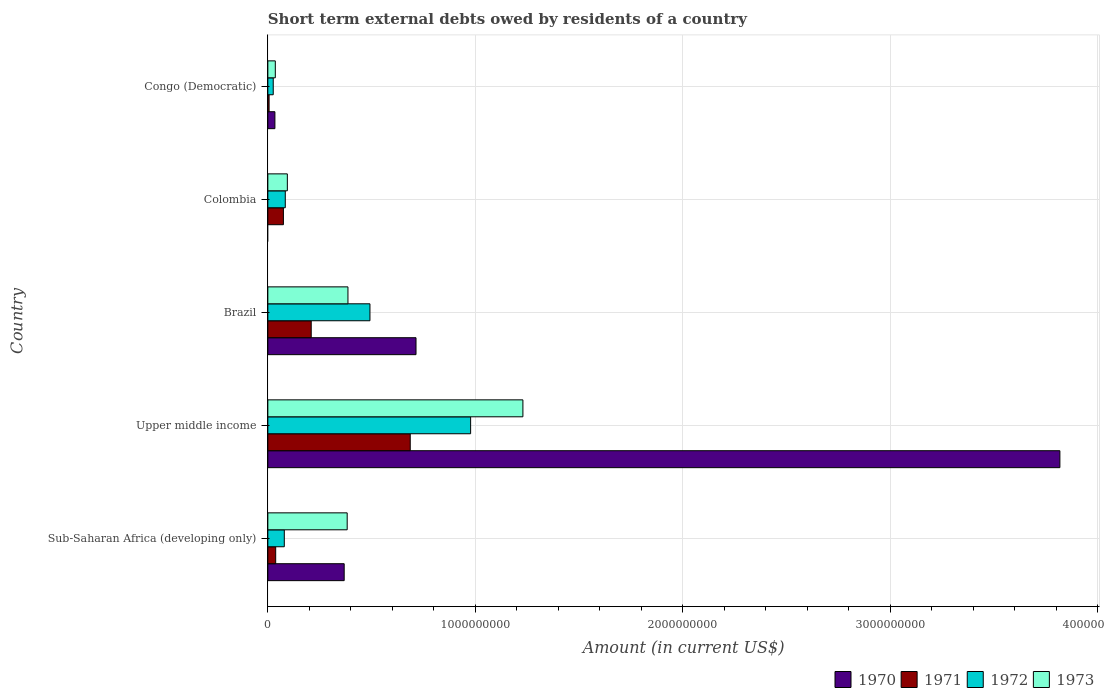How many bars are there on the 3rd tick from the bottom?
Your answer should be very brief. 4. What is the label of the 4th group of bars from the top?
Give a very brief answer. Upper middle income. In how many cases, is the number of bars for a given country not equal to the number of legend labels?
Your answer should be very brief. 1. What is the amount of short-term external debts owed by residents in 1970 in Upper middle income?
Your response must be concise. 3.82e+09. Across all countries, what is the maximum amount of short-term external debts owed by residents in 1970?
Make the answer very short. 3.82e+09. Across all countries, what is the minimum amount of short-term external debts owed by residents in 1972?
Your response must be concise. 2.60e+07. In which country was the amount of short-term external debts owed by residents in 1973 maximum?
Provide a succinct answer. Upper middle income. What is the total amount of short-term external debts owed by residents in 1971 in the graph?
Your response must be concise. 1.01e+09. What is the difference between the amount of short-term external debts owed by residents in 1972 in Congo (Democratic) and that in Sub-Saharan Africa (developing only)?
Provide a short and direct response. -5.33e+07. What is the difference between the amount of short-term external debts owed by residents in 1971 in Sub-Saharan Africa (developing only) and the amount of short-term external debts owed by residents in 1973 in Colombia?
Offer a very short reply. -5.62e+07. What is the average amount of short-term external debts owed by residents in 1970 per country?
Give a very brief answer. 9.87e+08. What is the difference between the amount of short-term external debts owed by residents in 1970 and amount of short-term external debts owed by residents in 1971 in Congo (Democratic)?
Your answer should be very brief. 2.80e+07. In how many countries, is the amount of short-term external debts owed by residents in 1972 greater than 3800000000 US$?
Provide a short and direct response. 0. What is the ratio of the amount of short-term external debts owed by residents in 1971 in Brazil to that in Sub-Saharan Africa (developing only)?
Your answer should be very brief. 5.53. Is the amount of short-term external debts owed by residents in 1971 in Colombia less than that in Sub-Saharan Africa (developing only)?
Keep it short and to the point. No. Is the difference between the amount of short-term external debts owed by residents in 1970 in Brazil and Upper middle income greater than the difference between the amount of short-term external debts owed by residents in 1971 in Brazil and Upper middle income?
Your response must be concise. No. What is the difference between the highest and the second highest amount of short-term external debts owed by residents in 1972?
Provide a short and direct response. 4.85e+08. What is the difference between the highest and the lowest amount of short-term external debts owed by residents in 1973?
Ensure brevity in your answer.  1.19e+09. Is the sum of the amount of short-term external debts owed by residents in 1971 in Brazil and Upper middle income greater than the maximum amount of short-term external debts owed by residents in 1972 across all countries?
Ensure brevity in your answer.  No. Is it the case that in every country, the sum of the amount of short-term external debts owed by residents in 1971 and amount of short-term external debts owed by residents in 1972 is greater than the amount of short-term external debts owed by residents in 1973?
Offer a terse response. No. How many bars are there?
Your response must be concise. 19. Are all the bars in the graph horizontal?
Provide a succinct answer. Yes. How many countries are there in the graph?
Give a very brief answer. 5. What is the difference between two consecutive major ticks on the X-axis?
Offer a very short reply. 1.00e+09. Are the values on the major ticks of X-axis written in scientific E-notation?
Give a very brief answer. No. Does the graph contain any zero values?
Your answer should be compact. Yes. Does the graph contain grids?
Give a very brief answer. Yes. Where does the legend appear in the graph?
Your answer should be very brief. Bottom right. How many legend labels are there?
Keep it short and to the point. 4. What is the title of the graph?
Ensure brevity in your answer.  Short term external debts owed by residents of a country. What is the Amount (in current US$) of 1970 in Sub-Saharan Africa (developing only)?
Ensure brevity in your answer.  3.68e+08. What is the Amount (in current US$) in 1971 in Sub-Saharan Africa (developing only)?
Make the answer very short. 3.78e+07. What is the Amount (in current US$) of 1972 in Sub-Saharan Africa (developing only)?
Your response must be concise. 7.93e+07. What is the Amount (in current US$) in 1973 in Sub-Saharan Africa (developing only)?
Give a very brief answer. 3.82e+08. What is the Amount (in current US$) of 1970 in Upper middle income?
Offer a very short reply. 3.82e+09. What is the Amount (in current US$) of 1971 in Upper middle income?
Your response must be concise. 6.86e+08. What is the Amount (in current US$) of 1972 in Upper middle income?
Offer a terse response. 9.77e+08. What is the Amount (in current US$) in 1973 in Upper middle income?
Your answer should be compact. 1.23e+09. What is the Amount (in current US$) in 1970 in Brazil?
Give a very brief answer. 7.14e+08. What is the Amount (in current US$) in 1971 in Brazil?
Provide a succinct answer. 2.09e+08. What is the Amount (in current US$) of 1972 in Brazil?
Offer a terse response. 4.92e+08. What is the Amount (in current US$) of 1973 in Brazil?
Give a very brief answer. 3.86e+08. What is the Amount (in current US$) in 1970 in Colombia?
Your answer should be very brief. 0. What is the Amount (in current US$) of 1971 in Colombia?
Offer a very short reply. 7.50e+07. What is the Amount (in current US$) of 1972 in Colombia?
Provide a short and direct response. 8.40e+07. What is the Amount (in current US$) in 1973 in Colombia?
Your answer should be very brief. 9.40e+07. What is the Amount (in current US$) of 1970 in Congo (Democratic)?
Provide a short and direct response. 3.40e+07. What is the Amount (in current US$) in 1972 in Congo (Democratic)?
Ensure brevity in your answer.  2.60e+07. What is the Amount (in current US$) in 1973 in Congo (Democratic)?
Make the answer very short. 3.60e+07. Across all countries, what is the maximum Amount (in current US$) of 1970?
Your answer should be very brief. 3.82e+09. Across all countries, what is the maximum Amount (in current US$) in 1971?
Provide a succinct answer. 6.86e+08. Across all countries, what is the maximum Amount (in current US$) of 1972?
Your answer should be compact. 9.77e+08. Across all countries, what is the maximum Amount (in current US$) in 1973?
Your answer should be very brief. 1.23e+09. Across all countries, what is the minimum Amount (in current US$) in 1970?
Your answer should be very brief. 0. Across all countries, what is the minimum Amount (in current US$) in 1972?
Ensure brevity in your answer.  2.60e+07. Across all countries, what is the minimum Amount (in current US$) in 1973?
Provide a succinct answer. 3.60e+07. What is the total Amount (in current US$) of 1970 in the graph?
Your response must be concise. 4.93e+09. What is the total Amount (in current US$) of 1971 in the graph?
Your answer should be very brief. 1.01e+09. What is the total Amount (in current US$) in 1972 in the graph?
Your answer should be compact. 1.66e+09. What is the total Amount (in current US$) in 1973 in the graph?
Your answer should be very brief. 2.13e+09. What is the difference between the Amount (in current US$) in 1970 in Sub-Saharan Africa (developing only) and that in Upper middle income?
Ensure brevity in your answer.  -3.45e+09. What is the difference between the Amount (in current US$) of 1971 in Sub-Saharan Africa (developing only) and that in Upper middle income?
Offer a very short reply. -6.48e+08. What is the difference between the Amount (in current US$) in 1972 in Sub-Saharan Africa (developing only) and that in Upper middle income?
Provide a short and direct response. -8.98e+08. What is the difference between the Amount (in current US$) of 1973 in Sub-Saharan Africa (developing only) and that in Upper middle income?
Your response must be concise. -8.47e+08. What is the difference between the Amount (in current US$) in 1970 in Sub-Saharan Africa (developing only) and that in Brazil?
Your answer should be very brief. -3.46e+08. What is the difference between the Amount (in current US$) in 1971 in Sub-Saharan Africa (developing only) and that in Brazil?
Provide a short and direct response. -1.71e+08. What is the difference between the Amount (in current US$) in 1972 in Sub-Saharan Africa (developing only) and that in Brazil?
Offer a very short reply. -4.13e+08. What is the difference between the Amount (in current US$) of 1973 in Sub-Saharan Africa (developing only) and that in Brazil?
Make the answer very short. -3.69e+06. What is the difference between the Amount (in current US$) in 1971 in Sub-Saharan Africa (developing only) and that in Colombia?
Your response must be concise. -3.72e+07. What is the difference between the Amount (in current US$) in 1972 in Sub-Saharan Africa (developing only) and that in Colombia?
Offer a terse response. -4.69e+06. What is the difference between the Amount (in current US$) of 1973 in Sub-Saharan Africa (developing only) and that in Colombia?
Provide a succinct answer. 2.88e+08. What is the difference between the Amount (in current US$) in 1970 in Sub-Saharan Africa (developing only) and that in Congo (Democratic)?
Give a very brief answer. 3.34e+08. What is the difference between the Amount (in current US$) in 1971 in Sub-Saharan Africa (developing only) and that in Congo (Democratic)?
Keep it short and to the point. 3.18e+07. What is the difference between the Amount (in current US$) of 1972 in Sub-Saharan Africa (developing only) and that in Congo (Democratic)?
Ensure brevity in your answer.  5.33e+07. What is the difference between the Amount (in current US$) in 1973 in Sub-Saharan Africa (developing only) and that in Congo (Democratic)?
Offer a very short reply. 3.46e+08. What is the difference between the Amount (in current US$) in 1970 in Upper middle income and that in Brazil?
Ensure brevity in your answer.  3.10e+09. What is the difference between the Amount (in current US$) in 1971 in Upper middle income and that in Brazil?
Your answer should be very brief. 4.77e+08. What is the difference between the Amount (in current US$) of 1972 in Upper middle income and that in Brazil?
Your answer should be compact. 4.85e+08. What is the difference between the Amount (in current US$) in 1973 in Upper middle income and that in Brazil?
Offer a very short reply. 8.43e+08. What is the difference between the Amount (in current US$) of 1971 in Upper middle income and that in Colombia?
Ensure brevity in your answer.  6.11e+08. What is the difference between the Amount (in current US$) in 1972 in Upper middle income and that in Colombia?
Offer a terse response. 8.93e+08. What is the difference between the Amount (in current US$) of 1973 in Upper middle income and that in Colombia?
Offer a terse response. 1.14e+09. What is the difference between the Amount (in current US$) in 1970 in Upper middle income and that in Congo (Democratic)?
Offer a very short reply. 3.78e+09. What is the difference between the Amount (in current US$) of 1971 in Upper middle income and that in Congo (Democratic)?
Your answer should be compact. 6.80e+08. What is the difference between the Amount (in current US$) of 1972 in Upper middle income and that in Congo (Democratic)?
Offer a terse response. 9.51e+08. What is the difference between the Amount (in current US$) of 1973 in Upper middle income and that in Congo (Democratic)?
Offer a very short reply. 1.19e+09. What is the difference between the Amount (in current US$) of 1971 in Brazil and that in Colombia?
Your response must be concise. 1.34e+08. What is the difference between the Amount (in current US$) of 1972 in Brazil and that in Colombia?
Your answer should be very brief. 4.08e+08. What is the difference between the Amount (in current US$) of 1973 in Brazil and that in Colombia?
Offer a terse response. 2.92e+08. What is the difference between the Amount (in current US$) of 1970 in Brazil and that in Congo (Democratic)?
Your answer should be very brief. 6.80e+08. What is the difference between the Amount (in current US$) of 1971 in Brazil and that in Congo (Democratic)?
Make the answer very short. 2.03e+08. What is the difference between the Amount (in current US$) in 1972 in Brazil and that in Congo (Democratic)?
Offer a terse response. 4.66e+08. What is the difference between the Amount (in current US$) of 1973 in Brazil and that in Congo (Democratic)?
Provide a short and direct response. 3.50e+08. What is the difference between the Amount (in current US$) of 1971 in Colombia and that in Congo (Democratic)?
Make the answer very short. 6.90e+07. What is the difference between the Amount (in current US$) of 1972 in Colombia and that in Congo (Democratic)?
Provide a short and direct response. 5.80e+07. What is the difference between the Amount (in current US$) of 1973 in Colombia and that in Congo (Democratic)?
Make the answer very short. 5.80e+07. What is the difference between the Amount (in current US$) in 1970 in Sub-Saharan Africa (developing only) and the Amount (in current US$) in 1971 in Upper middle income?
Your answer should be very brief. -3.18e+08. What is the difference between the Amount (in current US$) in 1970 in Sub-Saharan Africa (developing only) and the Amount (in current US$) in 1972 in Upper middle income?
Offer a terse response. -6.09e+08. What is the difference between the Amount (in current US$) in 1970 in Sub-Saharan Africa (developing only) and the Amount (in current US$) in 1973 in Upper middle income?
Offer a terse response. -8.61e+08. What is the difference between the Amount (in current US$) of 1971 in Sub-Saharan Africa (developing only) and the Amount (in current US$) of 1972 in Upper middle income?
Offer a terse response. -9.39e+08. What is the difference between the Amount (in current US$) in 1971 in Sub-Saharan Africa (developing only) and the Amount (in current US$) in 1973 in Upper middle income?
Offer a very short reply. -1.19e+09. What is the difference between the Amount (in current US$) of 1972 in Sub-Saharan Africa (developing only) and the Amount (in current US$) of 1973 in Upper middle income?
Offer a very short reply. -1.15e+09. What is the difference between the Amount (in current US$) in 1970 in Sub-Saharan Africa (developing only) and the Amount (in current US$) in 1971 in Brazil?
Provide a short and direct response. 1.59e+08. What is the difference between the Amount (in current US$) of 1970 in Sub-Saharan Africa (developing only) and the Amount (in current US$) of 1972 in Brazil?
Provide a succinct answer. -1.24e+08. What is the difference between the Amount (in current US$) of 1970 in Sub-Saharan Africa (developing only) and the Amount (in current US$) of 1973 in Brazil?
Give a very brief answer. -1.81e+07. What is the difference between the Amount (in current US$) in 1971 in Sub-Saharan Africa (developing only) and the Amount (in current US$) in 1972 in Brazil?
Provide a succinct answer. -4.54e+08. What is the difference between the Amount (in current US$) of 1971 in Sub-Saharan Africa (developing only) and the Amount (in current US$) of 1973 in Brazil?
Offer a very short reply. -3.48e+08. What is the difference between the Amount (in current US$) in 1972 in Sub-Saharan Africa (developing only) and the Amount (in current US$) in 1973 in Brazil?
Make the answer very short. -3.07e+08. What is the difference between the Amount (in current US$) of 1970 in Sub-Saharan Africa (developing only) and the Amount (in current US$) of 1971 in Colombia?
Your answer should be very brief. 2.93e+08. What is the difference between the Amount (in current US$) in 1970 in Sub-Saharan Africa (developing only) and the Amount (in current US$) in 1972 in Colombia?
Provide a succinct answer. 2.84e+08. What is the difference between the Amount (in current US$) of 1970 in Sub-Saharan Africa (developing only) and the Amount (in current US$) of 1973 in Colombia?
Ensure brevity in your answer.  2.74e+08. What is the difference between the Amount (in current US$) of 1971 in Sub-Saharan Africa (developing only) and the Amount (in current US$) of 1972 in Colombia?
Ensure brevity in your answer.  -4.62e+07. What is the difference between the Amount (in current US$) in 1971 in Sub-Saharan Africa (developing only) and the Amount (in current US$) in 1973 in Colombia?
Offer a very short reply. -5.62e+07. What is the difference between the Amount (in current US$) of 1972 in Sub-Saharan Africa (developing only) and the Amount (in current US$) of 1973 in Colombia?
Ensure brevity in your answer.  -1.47e+07. What is the difference between the Amount (in current US$) of 1970 in Sub-Saharan Africa (developing only) and the Amount (in current US$) of 1971 in Congo (Democratic)?
Keep it short and to the point. 3.62e+08. What is the difference between the Amount (in current US$) of 1970 in Sub-Saharan Africa (developing only) and the Amount (in current US$) of 1972 in Congo (Democratic)?
Your answer should be very brief. 3.42e+08. What is the difference between the Amount (in current US$) of 1970 in Sub-Saharan Africa (developing only) and the Amount (in current US$) of 1973 in Congo (Democratic)?
Make the answer very short. 3.32e+08. What is the difference between the Amount (in current US$) of 1971 in Sub-Saharan Africa (developing only) and the Amount (in current US$) of 1972 in Congo (Democratic)?
Give a very brief answer. 1.18e+07. What is the difference between the Amount (in current US$) of 1971 in Sub-Saharan Africa (developing only) and the Amount (in current US$) of 1973 in Congo (Democratic)?
Provide a succinct answer. 1.81e+06. What is the difference between the Amount (in current US$) of 1972 in Sub-Saharan Africa (developing only) and the Amount (in current US$) of 1973 in Congo (Democratic)?
Your response must be concise. 4.33e+07. What is the difference between the Amount (in current US$) of 1970 in Upper middle income and the Amount (in current US$) of 1971 in Brazil?
Offer a very short reply. 3.61e+09. What is the difference between the Amount (in current US$) of 1970 in Upper middle income and the Amount (in current US$) of 1972 in Brazil?
Make the answer very short. 3.32e+09. What is the difference between the Amount (in current US$) in 1970 in Upper middle income and the Amount (in current US$) in 1973 in Brazil?
Your answer should be very brief. 3.43e+09. What is the difference between the Amount (in current US$) in 1971 in Upper middle income and the Amount (in current US$) in 1972 in Brazil?
Offer a terse response. 1.94e+08. What is the difference between the Amount (in current US$) of 1971 in Upper middle income and the Amount (in current US$) of 1973 in Brazil?
Your answer should be compact. 3.00e+08. What is the difference between the Amount (in current US$) in 1972 in Upper middle income and the Amount (in current US$) in 1973 in Brazil?
Give a very brief answer. 5.91e+08. What is the difference between the Amount (in current US$) in 1970 in Upper middle income and the Amount (in current US$) in 1971 in Colombia?
Your answer should be compact. 3.74e+09. What is the difference between the Amount (in current US$) of 1970 in Upper middle income and the Amount (in current US$) of 1972 in Colombia?
Your response must be concise. 3.73e+09. What is the difference between the Amount (in current US$) in 1970 in Upper middle income and the Amount (in current US$) in 1973 in Colombia?
Ensure brevity in your answer.  3.72e+09. What is the difference between the Amount (in current US$) of 1971 in Upper middle income and the Amount (in current US$) of 1972 in Colombia?
Make the answer very short. 6.02e+08. What is the difference between the Amount (in current US$) in 1971 in Upper middle income and the Amount (in current US$) in 1973 in Colombia?
Your response must be concise. 5.92e+08. What is the difference between the Amount (in current US$) in 1972 in Upper middle income and the Amount (in current US$) in 1973 in Colombia?
Provide a short and direct response. 8.83e+08. What is the difference between the Amount (in current US$) in 1970 in Upper middle income and the Amount (in current US$) in 1971 in Congo (Democratic)?
Provide a short and direct response. 3.81e+09. What is the difference between the Amount (in current US$) of 1970 in Upper middle income and the Amount (in current US$) of 1972 in Congo (Democratic)?
Ensure brevity in your answer.  3.79e+09. What is the difference between the Amount (in current US$) of 1970 in Upper middle income and the Amount (in current US$) of 1973 in Congo (Democratic)?
Offer a terse response. 3.78e+09. What is the difference between the Amount (in current US$) of 1971 in Upper middle income and the Amount (in current US$) of 1972 in Congo (Democratic)?
Your answer should be compact. 6.60e+08. What is the difference between the Amount (in current US$) in 1971 in Upper middle income and the Amount (in current US$) in 1973 in Congo (Democratic)?
Give a very brief answer. 6.50e+08. What is the difference between the Amount (in current US$) of 1972 in Upper middle income and the Amount (in current US$) of 1973 in Congo (Democratic)?
Keep it short and to the point. 9.41e+08. What is the difference between the Amount (in current US$) in 1970 in Brazil and the Amount (in current US$) in 1971 in Colombia?
Provide a succinct answer. 6.39e+08. What is the difference between the Amount (in current US$) in 1970 in Brazil and the Amount (in current US$) in 1972 in Colombia?
Ensure brevity in your answer.  6.30e+08. What is the difference between the Amount (in current US$) in 1970 in Brazil and the Amount (in current US$) in 1973 in Colombia?
Your answer should be compact. 6.20e+08. What is the difference between the Amount (in current US$) of 1971 in Brazil and the Amount (in current US$) of 1972 in Colombia?
Your answer should be very brief. 1.25e+08. What is the difference between the Amount (in current US$) of 1971 in Brazil and the Amount (in current US$) of 1973 in Colombia?
Make the answer very short. 1.15e+08. What is the difference between the Amount (in current US$) in 1972 in Brazil and the Amount (in current US$) in 1973 in Colombia?
Give a very brief answer. 3.98e+08. What is the difference between the Amount (in current US$) in 1970 in Brazil and the Amount (in current US$) in 1971 in Congo (Democratic)?
Give a very brief answer. 7.08e+08. What is the difference between the Amount (in current US$) in 1970 in Brazil and the Amount (in current US$) in 1972 in Congo (Democratic)?
Your response must be concise. 6.88e+08. What is the difference between the Amount (in current US$) of 1970 in Brazil and the Amount (in current US$) of 1973 in Congo (Democratic)?
Give a very brief answer. 6.78e+08. What is the difference between the Amount (in current US$) in 1971 in Brazil and the Amount (in current US$) in 1972 in Congo (Democratic)?
Keep it short and to the point. 1.83e+08. What is the difference between the Amount (in current US$) in 1971 in Brazil and the Amount (in current US$) in 1973 in Congo (Democratic)?
Provide a short and direct response. 1.73e+08. What is the difference between the Amount (in current US$) of 1972 in Brazil and the Amount (in current US$) of 1973 in Congo (Democratic)?
Provide a succinct answer. 4.56e+08. What is the difference between the Amount (in current US$) in 1971 in Colombia and the Amount (in current US$) in 1972 in Congo (Democratic)?
Provide a short and direct response. 4.90e+07. What is the difference between the Amount (in current US$) of 1971 in Colombia and the Amount (in current US$) of 1973 in Congo (Democratic)?
Your response must be concise. 3.90e+07. What is the difference between the Amount (in current US$) in 1972 in Colombia and the Amount (in current US$) in 1973 in Congo (Democratic)?
Offer a terse response. 4.80e+07. What is the average Amount (in current US$) in 1970 per country?
Ensure brevity in your answer.  9.87e+08. What is the average Amount (in current US$) of 1971 per country?
Provide a short and direct response. 2.03e+08. What is the average Amount (in current US$) in 1972 per country?
Your response must be concise. 3.32e+08. What is the average Amount (in current US$) of 1973 per country?
Provide a succinct answer. 4.25e+08. What is the difference between the Amount (in current US$) in 1970 and Amount (in current US$) in 1971 in Sub-Saharan Africa (developing only)?
Keep it short and to the point. 3.30e+08. What is the difference between the Amount (in current US$) of 1970 and Amount (in current US$) of 1972 in Sub-Saharan Africa (developing only)?
Provide a short and direct response. 2.89e+08. What is the difference between the Amount (in current US$) of 1970 and Amount (in current US$) of 1973 in Sub-Saharan Africa (developing only)?
Keep it short and to the point. -1.44e+07. What is the difference between the Amount (in current US$) in 1971 and Amount (in current US$) in 1972 in Sub-Saharan Africa (developing only)?
Ensure brevity in your answer.  -4.15e+07. What is the difference between the Amount (in current US$) in 1971 and Amount (in current US$) in 1973 in Sub-Saharan Africa (developing only)?
Keep it short and to the point. -3.45e+08. What is the difference between the Amount (in current US$) of 1972 and Amount (in current US$) of 1973 in Sub-Saharan Africa (developing only)?
Offer a terse response. -3.03e+08. What is the difference between the Amount (in current US$) of 1970 and Amount (in current US$) of 1971 in Upper middle income?
Keep it short and to the point. 3.13e+09. What is the difference between the Amount (in current US$) in 1970 and Amount (in current US$) in 1972 in Upper middle income?
Your answer should be compact. 2.84e+09. What is the difference between the Amount (in current US$) in 1970 and Amount (in current US$) in 1973 in Upper middle income?
Make the answer very short. 2.59e+09. What is the difference between the Amount (in current US$) in 1971 and Amount (in current US$) in 1972 in Upper middle income?
Provide a succinct answer. -2.91e+08. What is the difference between the Amount (in current US$) in 1971 and Amount (in current US$) in 1973 in Upper middle income?
Provide a short and direct response. -5.43e+08. What is the difference between the Amount (in current US$) of 1972 and Amount (in current US$) of 1973 in Upper middle income?
Your answer should be compact. -2.52e+08. What is the difference between the Amount (in current US$) of 1970 and Amount (in current US$) of 1971 in Brazil?
Keep it short and to the point. 5.05e+08. What is the difference between the Amount (in current US$) in 1970 and Amount (in current US$) in 1972 in Brazil?
Offer a terse response. 2.22e+08. What is the difference between the Amount (in current US$) of 1970 and Amount (in current US$) of 1973 in Brazil?
Your answer should be very brief. 3.28e+08. What is the difference between the Amount (in current US$) in 1971 and Amount (in current US$) in 1972 in Brazil?
Provide a short and direct response. -2.83e+08. What is the difference between the Amount (in current US$) in 1971 and Amount (in current US$) in 1973 in Brazil?
Your response must be concise. -1.77e+08. What is the difference between the Amount (in current US$) in 1972 and Amount (in current US$) in 1973 in Brazil?
Your answer should be very brief. 1.06e+08. What is the difference between the Amount (in current US$) of 1971 and Amount (in current US$) of 1972 in Colombia?
Ensure brevity in your answer.  -9.00e+06. What is the difference between the Amount (in current US$) of 1971 and Amount (in current US$) of 1973 in Colombia?
Keep it short and to the point. -1.90e+07. What is the difference between the Amount (in current US$) in 1972 and Amount (in current US$) in 1973 in Colombia?
Provide a short and direct response. -1.00e+07. What is the difference between the Amount (in current US$) of 1970 and Amount (in current US$) of 1971 in Congo (Democratic)?
Ensure brevity in your answer.  2.80e+07. What is the difference between the Amount (in current US$) in 1970 and Amount (in current US$) in 1972 in Congo (Democratic)?
Your answer should be compact. 8.00e+06. What is the difference between the Amount (in current US$) in 1971 and Amount (in current US$) in 1972 in Congo (Democratic)?
Keep it short and to the point. -2.00e+07. What is the difference between the Amount (in current US$) in 1971 and Amount (in current US$) in 1973 in Congo (Democratic)?
Your answer should be very brief. -3.00e+07. What is the difference between the Amount (in current US$) in 1972 and Amount (in current US$) in 1973 in Congo (Democratic)?
Keep it short and to the point. -1.00e+07. What is the ratio of the Amount (in current US$) of 1970 in Sub-Saharan Africa (developing only) to that in Upper middle income?
Provide a succinct answer. 0.1. What is the ratio of the Amount (in current US$) of 1971 in Sub-Saharan Africa (developing only) to that in Upper middle income?
Your response must be concise. 0.06. What is the ratio of the Amount (in current US$) of 1972 in Sub-Saharan Africa (developing only) to that in Upper middle income?
Provide a succinct answer. 0.08. What is the ratio of the Amount (in current US$) of 1973 in Sub-Saharan Africa (developing only) to that in Upper middle income?
Provide a succinct answer. 0.31. What is the ratio of the Amount (in current US$) of 1970 in Sub-Saharan Africa (developing only) to that in Brazil?
Your answer should be compact. 0.52. What is the ratio of the Amount (in current US$) in 1971 in Sub-Saharan Africa (developing only) to that in Brazil?
Make the answer very short. 0.18. What is the ratio of the Amount (in current US$) in 1972 in Sub-Saharan Africa (developing only) to that in Brazil?
Your response must be concise. 0.16. What is the ratio of the Amount (in current US$) in 1971 in Sub-Saharan Africa (developing only) to that in Colombia?
Give a very brief answer. 0.5. What is the ratio of the Amount (in current US$) of 1972 in Sub-Saharan Africa (developing only) to that in Colombia?
Your response must be concise. 0.94. What is the ratio of the Amount (in current US$) in 1973 in Sub-Saharan Africa (developing only) to that in Colombia?
Provide a succinct answer. 4.07. What is the ratio of the Amount (in current US$) in 1970 in Sub-Saharan Africa (developing only) to that in Congo (Democratic)?
Your answer should be very brief. 10.82. What is the ratio of the Amount (in current US$) of 1971 in Sub-Saharan Africa (developing only) to that in Congo (Democratic)?
Your response must be concise. 6.3. What is the ratio of the Amount (in current US$) of 1972 in Sub-Saharan Africa (developing only) to that in Congo (Democratic)?
Offer a terse response. 3.05. What is the ratio of the Amount (in current US$) of 1973 in Sub-Saharan Africa (developing only) to that in Congo (Democratic)?
Provide a short and direct response. 10.62. What is the ratio of the Amount (in current US$) of 1970 in Upper middle income to that in Brazil?
Keep it short and to the point. 5.35. What is the ratio of the Amount (in current US$) of 1971 in Upper middle income to that in Brazil?
Give a very brief answer. 3.28. What is the ratio of the Amount (in current US$) in 1972 in Upper middle income to that in Brazil?
Ensure brevity in your answer.  1.99. What is the ratio of the Amount (in current US$) of 1973 in Upper middle income to that in Brazil?
Provide a succinct answer. 3.18. What is the ratio of the Amount (in current US$) of 1971 in Upper middle income to that in Colombia?
Provide a short and direct response. 9.15. What is the ratio of the Amount (in current US$) in 1972 in Upper middle income to that in Colombia?
Keep it short and to the point. 11.63. What is the ratio of the Amount (in current US$) in 1973 in Upper middle income to that in Colombia?
Ensure brevity in your answer.  13.08. What is the ratio of the Amount (in current US$) of 1970 in Upper middle income to that in Congo (Democratic)?
Offer a terse response. 112.25. What is the ratio of the Amount (in current US$) in 1971 in Upper middle income to that in Congo (Democratic)?
Your answer should be compact. 114.35. What is the ratio of the Amount (in current US$) of 1972 in Upper middle income to that in Congo (Democratic)?
Provide a short and direct response. 37.58. What is the ratio of the Amount (in current US$) in 1973 in Upper middle income to that in Congo (Democratic)?
Provide a short and direct response. 34.14. What is the ratio of the Amount (in current US$) in 1971 in Brazil to that in Colombia?
Your answer should be compact. 2.79. What is the ratio of the Amount (in current US$) of 1972 in Brazil to that in Colombia?
Ensure brevity in your answer.  5.86. What is the ratio of the Amount (in current US$) of 1973 in Brazil to that in Colombia?
Provide a succinct answer. 4.11. What is the ratio of the Amount (in current US$) of 1970 in Brazil to that in Congo (Democratic)?
Provide a succinct answer. 21. What is the ratio of the Amount (in current US$) of 1971 in Brazil to that in Congo (Democratic)?
Provide a succinct answer. 34.83. What is the ratio of the Amount (in current US$) in 1972 in Brazil to that in Congo (Democratic)?
Give a very brief answer. 18.92. What is the ratio of the Amount (in current US$) of 1973 in Brazil to that in Congo (Democratic)?
Provide a succinct answer. 10.72. What is the ratio of the Amount (in current US$) in 1971 in Colombia to that in Congo (Democratic)?
Give a very brief answer. 12.5. What is the ratio of the Amount (in current US$) of 1972 in Colombia to that in Congo (Democratic)?
Make the answer very short. 3.23. What is the ratio of the Amount (in current US$) of 1973 in Colombia to that in Congo (Democratic)?
Provide a succinct answer. 2.61. What is the difference between the highest and the second highest Amount (in current US$) in 1970?
Give a very brief answer. 3.10e+09. What is the difference between the highest and the second highest Amount (in current US$) in 1971?
Provide a succinct answer. 4.77e+08. What is the difference between the highest and the second highest Amount (in current US$) in 1972?
Your answer should be very brief. 4.85e+08. What is the difference between the highest and the second highest Amount (in current US$) in 1973?
Your answer should be compact. 8.43e+08. What is the difference between the highest and the lowest Amount (in current US$) in 1970?
Your response must be concise. 3.82e+09. What is the difference between the highest and the lowest Amount (in current US$) of 1971?
Offer a very short reply. 6.80e+08. What is the difference between the highest and the lowest Amount (in current US$) of 1972?
Your answer should be compact. 9.51e+08. What is the difference between the highest and the lowest Amount (in current US$) in 1973?
Provide a succinct answer. 1.19e+09. 